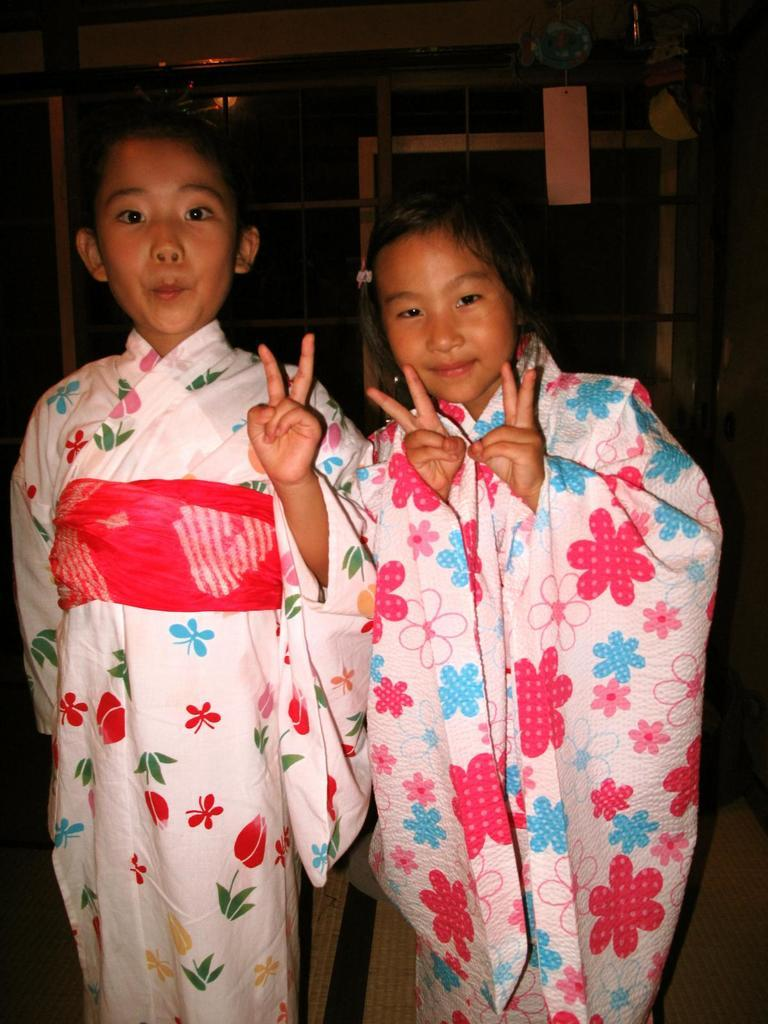How many people are present in the image? There are two people in the image, a boy and a girl. What are the positions of the boy and girl in the image? Both the boy and girl are standing on the floor. What can be seen in the background of the image? There is a cupboard visible in the background of the image. What type of dogs are playing with the children in the image? There are no dogs present in the image; it only features a boy and a girl standing on the floor. 